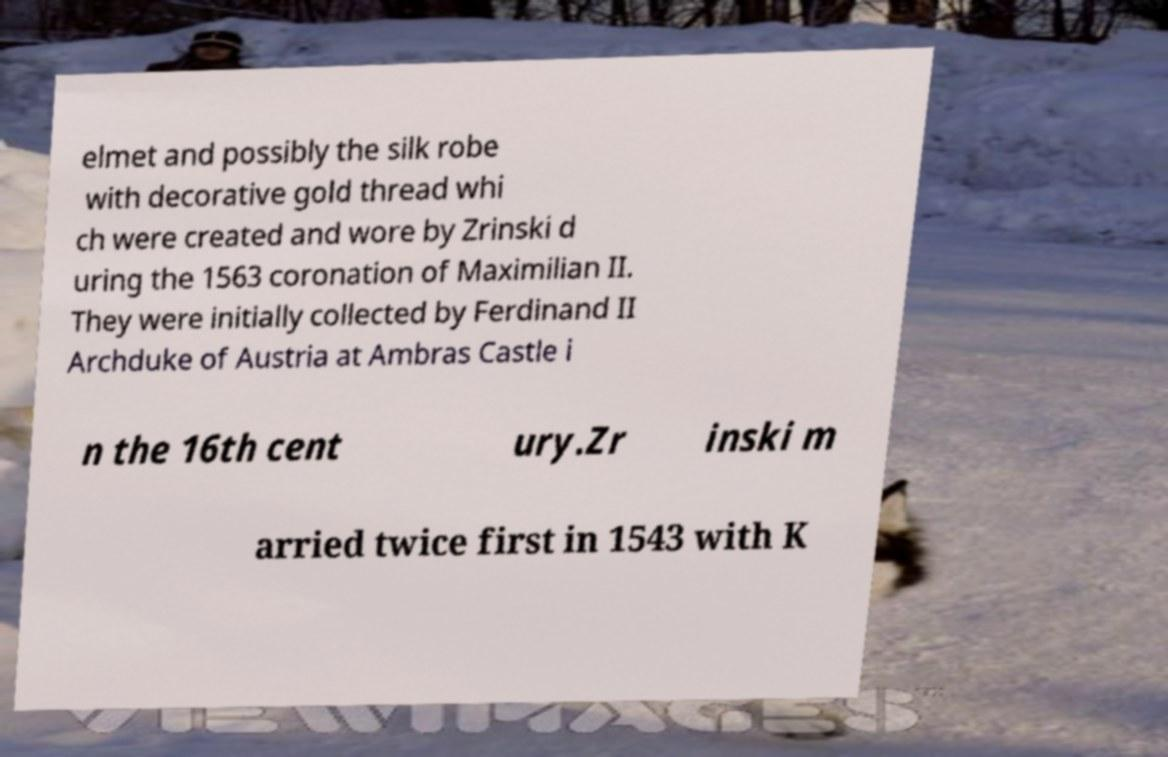What messages or text are displayed in this image? I need them in a readable, typed format. elmet and possibly the silk robe with decorative gold thread whi ch were created and wore by Zrinski d uring the 1563 coronation of Maximilian II. They were initially collected by Ferdinand II Archduke of Austria at Ambras Castle i n the 16th cent ury.Zr inski m arried twice first in 1543 with K 